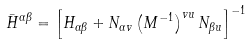Convert formula to latex. <formula><loc_0><loc_0><loc_500><loc_500>\bar { H } ^ { \alpha \beta } = \left [ H _ { \alpha \beta } + N _ { \alpha v } \left ( M ^ { - 1 } \right ) ^ { v u } N _ { \beta u } \right ] ^ { - 1 }</formula> 